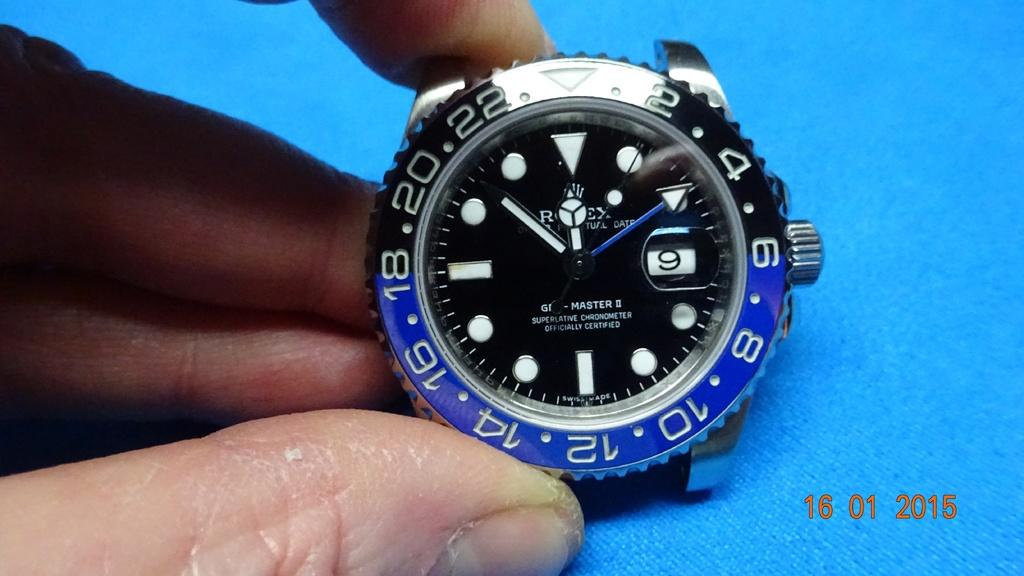Provide a one-sentence caption for the provided image. A Rolex watch is shown with a time stamp of the year 2015 to the right of it. 